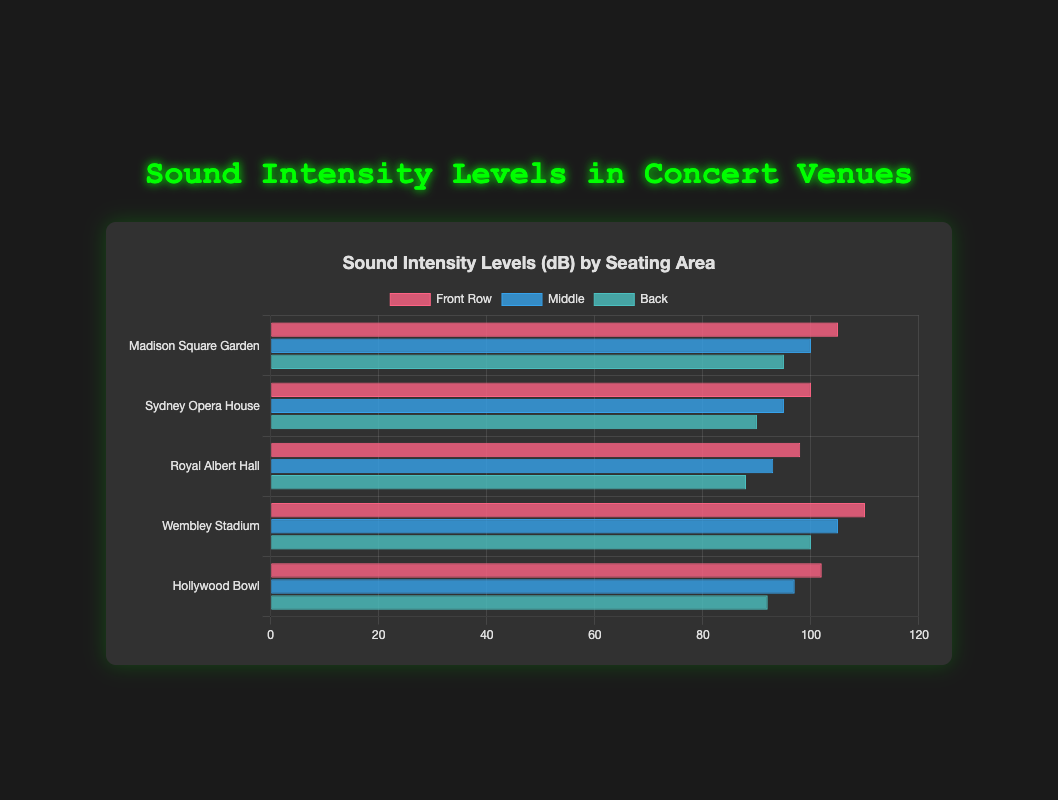Which venue has the highest sound intensity in the Front Row? Look at the bar representing the sound intensity for the Front Row seating area across all venues. The bar with the highest length and labeled value will indicate the venue with the highest sound intensity in the Front Row. Wembley Stadium has a Front Row intensity of 110 dB, the highest among the given venues.
Answer: Wembley Stadium How much louder is the Front Row compared to the Back in Madison Square Garden? Identify the sound intensity levels for both the Front Row and Back seating areas in Madison Square Garden. The values are 105 dB for Front Row and 95 dB for Back. Subtract the Back row level from the Front row level: 105 - 95 = 10 dB.
Answer: 10 dB Which venue has the least sound intensity in the Middle seating area? Examine all bars representing the Middle seating area for each venue. The shortest bar or the one with the lowest value will represent the venue with the least sound intensity. Royal Albert Hall has a Middle seating sound intensity of 93 dB.
Answer: Royal Albert Hall What is the average sound intensity for the Back seating area across all venues? Identify the sound intensity values for the Back seating area at each venue: 95, 90, 88, 100, and 92 dB. Sum these values and divide by the number of venues: (95 + 90 + 88 + 100 + 92) / 5 = 465 / 5 = 93 dB.
Answer: 93 dB Which seating area generally has the highest sound intensity levels across all venues? Compare the sound intensity bars across all venues for Front Row, Middle, and Back seating areas. The Front Row generally has the highest sound intensity levels in all venues based on the height and values of the bars.
Answer: Front Row Is the sound intensity in the Front Row of Hollywood Bowl higher or lower than the Middle seating area of Wembley Stadium? Check the values for the Front Row of Hollywood Bowl and the Middle seating area of Wembley Stadium. Hollywood Bowl's Front Row is 102 dB, and Wembley Stadium's Middle is 105 dB. Since 102 is less than 105, the sound intensity is lower in Hollywood Bowl's Front Row.
Answer: Lower What is the difference in sound intensity between the Front Row and Back seating areas in Sydney Opera House? Identify the sound intensity levels in Sydney Opera House for the Front Row and Back seating areas: 100 dB and 90 dB respectively. Subtract the Back row value from the Front Row value: 100 - 90 = 10 dB.
Answer: 10 dB What is the combined sound intensity for the Middle seating area at Royal Albert Hall and Sydney Opera House? Identify the sound intensity levels for the Middle seating area in both Royal Albert Hall and Sydney Opera House: 93 dB and 95 dB respectively. Add the two values: 93 + 95 = 188 dB.
Answer: 188 dB Which venue has the closest sound intensity levels between its Front Row and Middle seating areas? Calculate the absolute difference between Front Row and Middle sound intensities for each venue: Madison Square Garden (5), Sydney Opera House (5), Royal Albert Hall (5), Wembley Stadium (5), Hollywood Bowl (5). Since all values are the same, all venues have equally close levels between Front Row and Middle.
Answer: All venues 